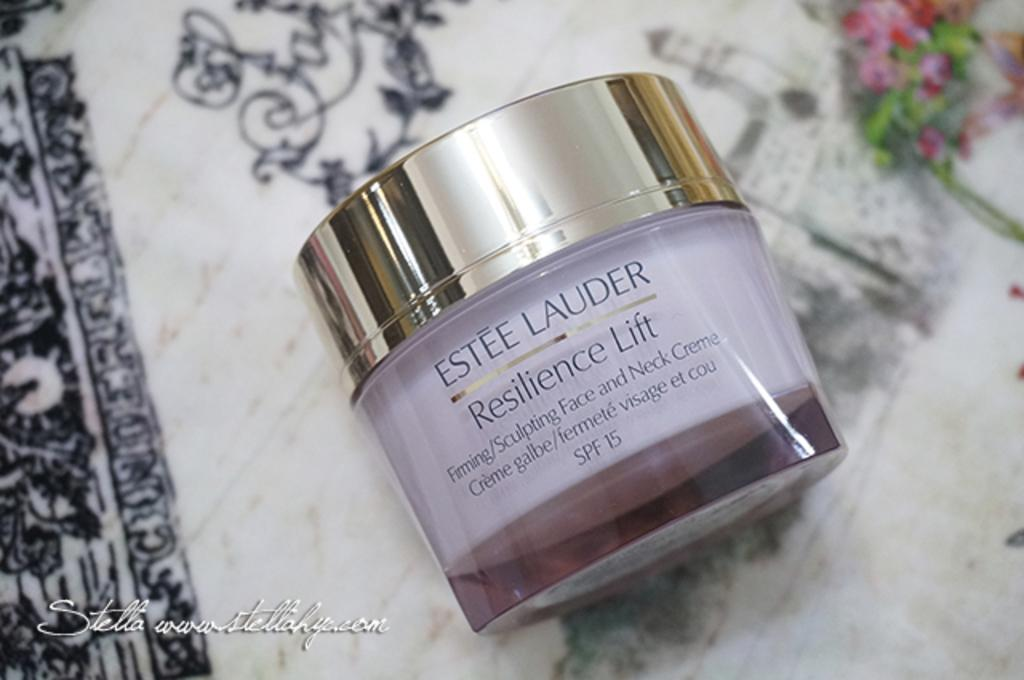<image>
Relay a brief, clear account of the picture shown. A bottle of Ester Lauder face cream called Resilience Lift. 